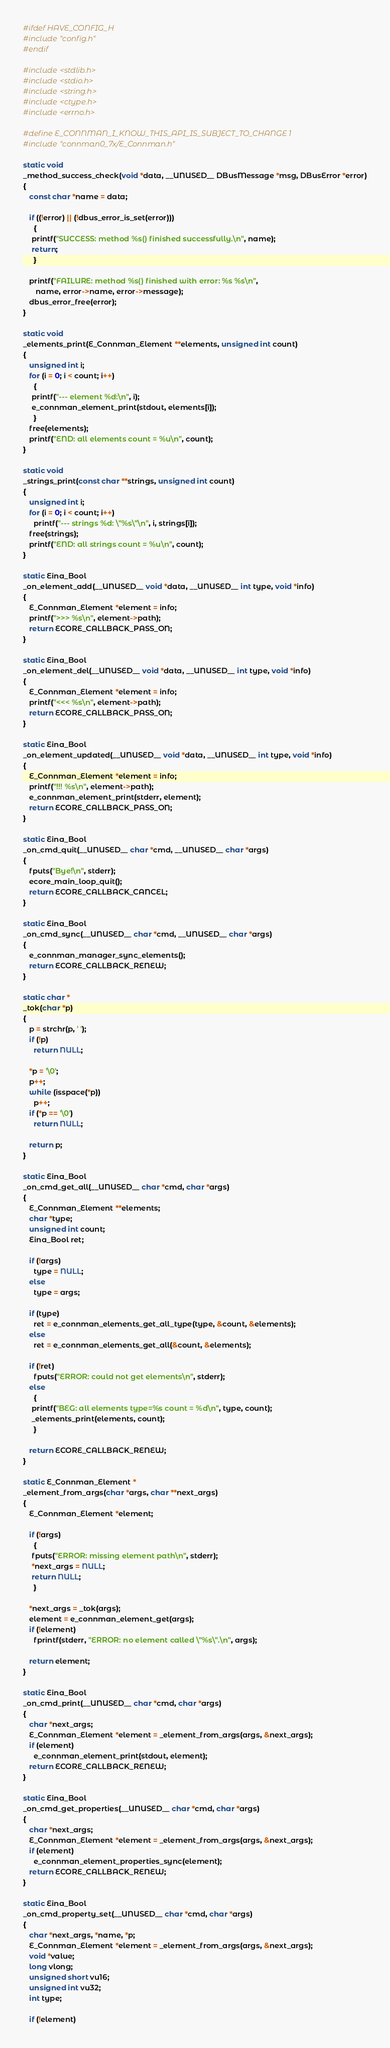<code> <loc_0><loc_0><loc_500><loc_500><_C_>#ifdef HAVE_CONFIG_H
#include "config.h"
#endif

#include <stdlib.h>
#include <stdio.h>
#include <string.h>
#include <ctype.h>
#include <errno.h>

#define E_CONNMAN_I_KNOW_THIS_API_IS_SUBJECT_TO_CHANGE 1
#include "connman0_7x/E_Connman.h"

static void
_method_success_check(void *data, __UNUSED__ DBusMessage *msg, DBusError *error)
{
   const char *name = data;

   if ((!error) || (!dbus_error_is_set(error)))
     {
	printf("SUCCESS: method %s() finished successfully.\n", name);
	return;
     }

   printf("FAILURE: method %s() finished with error: %s %s\n",
	  name, error->name, error->message);
   dbus_error_free(error);
}

static void
_elements_print(E_Connman_Element **elements, unsigned int count)
{
   unsigned int i;
   for (i = 0; i < count; i++)
     {
	printf("--- element %d:\n", i);
	e_connman_element_print(stdout, elements[i]);
     }
   free(elements);
   printf("END: all elements count = %u\n", count);
}

static void
_strings_print(const char **strings, unsigned int count)
{
   unsigned int i;
   for (i = 0; i < count; i++)
     printf("--- strings %d: \"%s\"\n", i, strings[i]);
   free(strings);
   printf("END: all strings count = %u\n", count);
}

static Eina_Bool
_on_element_add(__UNUSED__ void *data, __UNUSED__ int type, void *info)
{
   E_Connman_Element *element = info;
   printf(">>> %s\n", element->path);
   return ECORE_CALLBACK_PASS_ON;
}

static Eina_Bool
_on_element_del(__UNUSED__ void *data, __UNUSED__ int type, void *info)
{
   E_Connman_Element *element = info;
   printf("<<< %s\n", element->path);
   return ECORE_CALLBACK_PASS_ON;
}

static Eina_Bool
_on_element_updated(__UNUSED__ void *data, __UNUSED__ int type, void *info)
{
   E_Connman_Element *element = info;
   printf("!!! %s\n", element->path);
   e_connman_element_print(stderr, element);
   return ECORE_CALLBACK_PASS_ON;
}

static Eina_Bool
_on_cmd_quit(__UNUSED__ char *cmd, __UNUSED__ char *args)
{
   fputs("Bye!\n", stderr);
   ecore_main_loop_quit();
   return ECORE_CALLBACK_CANCEL;
}

static Eina_Bool
_on_cmd_sync(__UNUSED__ char *cmd, __UNUSED__ char *args)
{
   e_connman_manager_sync_elements();
   return ECORE_CALLBACK_RENEW;
}

static char *
_tok(char *p)
{
   p = strchr(p, ' ');
   if (!p)
     return NULL;

   *p = '\0';
   p++;
   while (isspace(*p))
     p++;
   if (*p == '\0')
     return NULL;

   return p;
}

static Eina_Bool
_on_cmd_get_all(__UNUSED__ char *cmd, char *args)
{
   E_Connman_Element **elements;
   char *type;
   unsigned int count;
   Eina_Bool ret;

   if (!args)
     type = NULL;
   else
     type = args;

   if (type)
     ret = e_connman_elements_get_all_type(type, &count, &elements);
   else
     ret = e_connman_elements_get_all(&count, &elements);

   if (!ret)
     fputs("ERROR: could not get elements\n", stderr);
   else
     {
	printf("BEG: all elements type=%s count = %d\n", type, count);
	_elements_print(elements, count);
     }

   return ECORE_CALLBACK_RENEW;
}

static E_Connman_Element *
_element_from_args(char *args, char **next_args)
{
   E_Connman_Element *element;

   if (!args)
     {
	fputs("ERROR: missing element path\n", stderr);
	*next_args = NULL;
	return NULL;
     }

   *next_args = _tok(args);
   element = e_connman_element_get(args);
   if (!element)
     fprintf(stderr, "ERROR: no element called \"%s\".\n", args);

   return element;
}

static Eina_Bool
_on_cmd_print(__UNUSED__ char *cmd, char *args)
{
   char *next_args;
   E_Connman_Element *element = _element_from_args(args, &next_args);
   if (element)
     e_connman_element_print(stdout, element);
   return ECORE_CALLBACK_RENEW;
}

static Eina_Bool
_on_cmd_get_properties(__UNUSED__ char *cmd, char *args)
{
   char *next_args;
   E_Connman_Element *element = _element_from_args(args, &next_args);
   if (element)
     e_connman_element_properties_sync(element);
   return ECORE_CALLBACK_RENEW;
}

static Eina_Bool
_on_cmd_property_set(__UNUSED__ char *cmd, char *args)
{
   char *next_args, *name, *p;
   E_Connman_Element *element = _element_from_args(args, &next_args);
   void *value;
   long vlong;
   unsigned short vu16;
   unsigned int vu32;
   int type;

   if (!element)</code> 